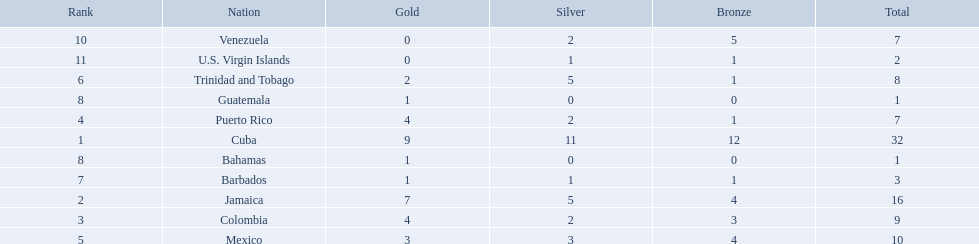Which countries competed in the 1966 central american and caribbean games? Cuba, Jamaica, Colombia, Puerto Rico, Mexico, Trinidad and Tobago, Barbados, Guatemala, Bahamas, Venezuela, U.S. Virgin Islands. Which countries won at least six silver medals at these games? Cuba. 